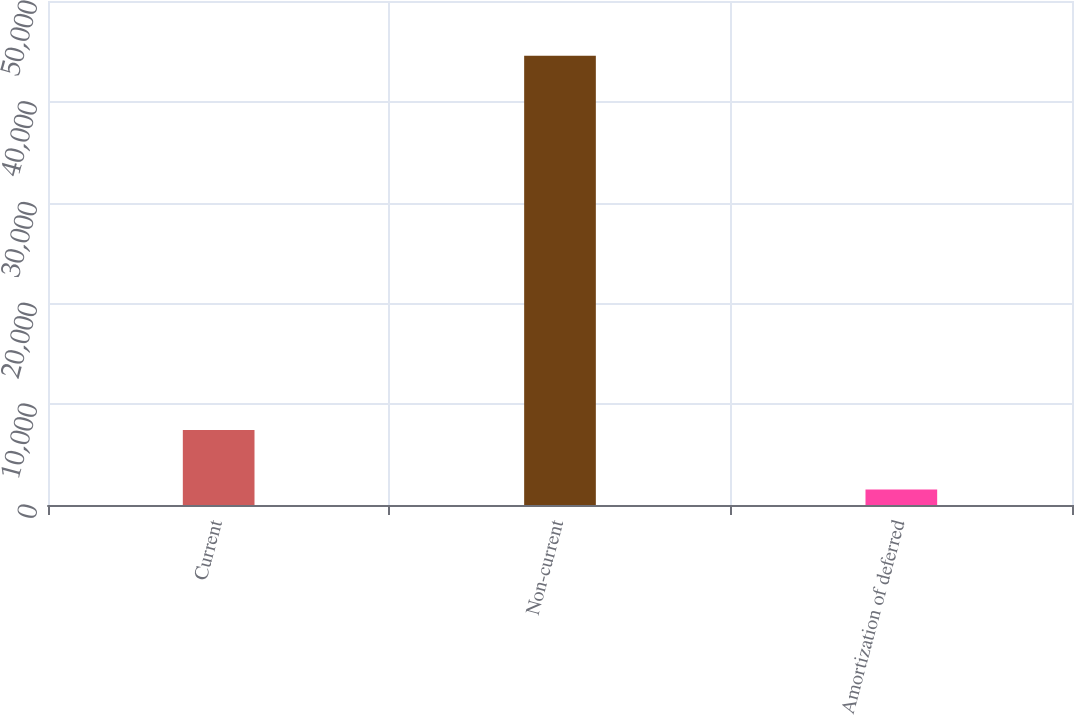Convert chart. <chart><loc_0><loc_0><loc_500><loc_500><bar_chart><fcel>Current<fcel>Non-current<fcel>Amortization of deferred<nl><fcel>7440<fcel>44576<fcel>1542<nl></chart> 